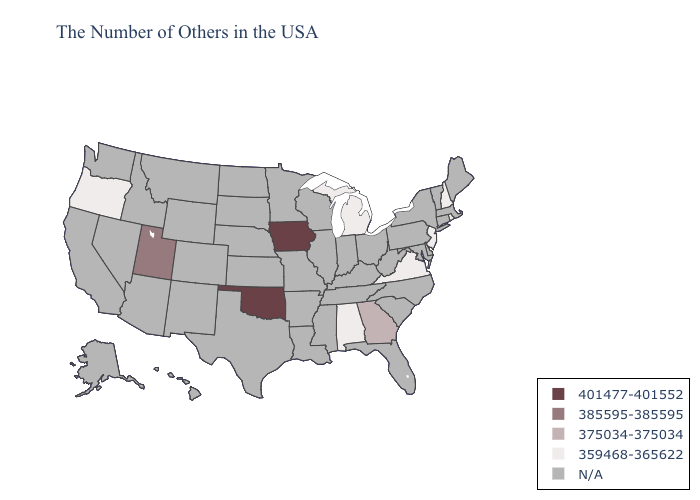Which states have the lowest value in the MidWest?
Be succinct. Michigan. Which states have the highest value in the USA?
Short answer required. Iowa, Oklahoma. Name the states that have a value in the range N/A?
Concise answer only. Maine, Massachusetts, Vermont, Connecticut, New York, Delaware, Maryland, Pennsylvania, North Carolina, South Carolina, West Virginia, Ohio, Florida, Kentucky, Indiana, Tennessee, Wisconsin, Illinois, Mississippi, Louisiana, Missouri, Arkansas, Minnesota, Kansas, Nebraska, Texas, South Dakota, North Dakota, Wyoming, Colorado, New Mexico, Montana, Arizona, Idaho, Nevada, California, Washington, Alaska, Hawaii. What is the highest value in states that border South Carolina?
Keep it brief. 375034-375034. What is the value of Nevada?
Short answer required. N/A. What is the value of New Hampshire?
Answer briefly. 359468-365622. Does the map have missing data?
Answer briefly. Yes. What is the value of Pennsylvania?
Be succinct. N/A. What is the value of Georgia?
Quick response, please. 375034-375034. What is the value of Maryland?
Short answer required. N/A. Does Oklahoma have the highest value in the South?
Answer briefly. Yes. What is the value of Arkansas?
Concise answer only. N/A. Does Alabama have the lowest value in the USA?
Short answer required. Yes. 